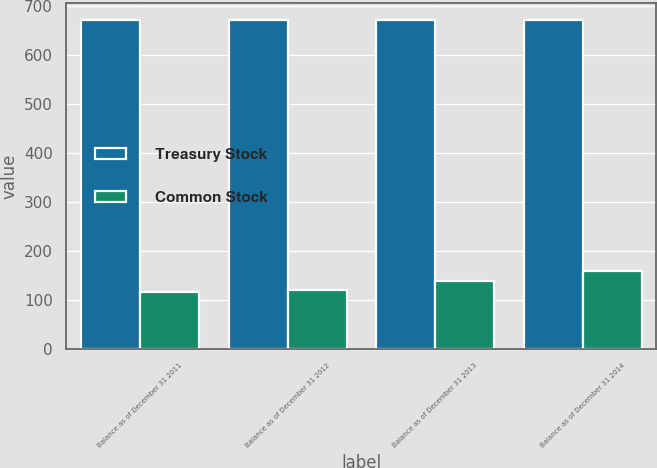Convert chart to OTSL. <chart><loc_0><loc_0><loc_500><loc_500><stacked_bar_chart><ecel><fcel>Balance as of December 31 2011<fcel>Balance as of December 31 2012<fcel>Balance as of December 31 2013<fcel>Balance as of December 31 2014<nl><fcel>Treasury Stock<fcel>673<fcel>673<fcel>673<fcel>673<nl><fcel>Common Stock<fcel>117<fcel>121<fcel>138<fcel>159<nl></chart> 